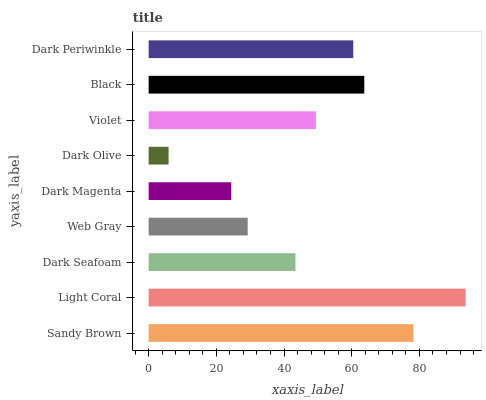Is Dark Olive the minimum?
Answer yes or no. Yes. Is Light Coral the maximum?
Answer yes or no. Yes. Is Dark Seafoam the minimum?
Answer yes or no. No. Is Dark Seafoam the maximum?
Answer yes or no. No. Is Light Coral greater than Dark Seafoam?
Answer yes or no. Yes. Is Dark Seafoam less than Light Coral?
Answer yes or no. Yes. Is Dark Seafoam greater than Light Coral?
Answer yes or no. No. Is Light Coral less than Dark Seafoam?
Answer yes or no. No. Is Violet the high median?
Answer yes or no. Yes. Is Violet the low median?
Answer yes or no. Yes. Is Dark Olive the high median?
Answer yes or no. No. Is Light Coral the low median?
Answer yes or no. No. 